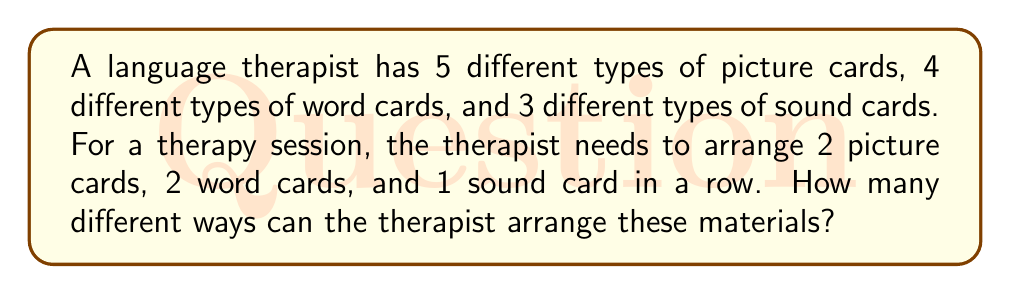Show me your answer to this math problem. Let's break this down step-by-step:

1) First, we need to choose the cards:
   - 2 picture cards out of 5: $\binom{5}{2}$
   - 2 word cards out of 4: $\binom{4}{2}$
   - 1 sound card out of 3: $\binom{3}{1}$

2) The number of ways to choose the cards is:
   $$\binom{5}{2} \cdot \binom{4}{2} \cdot \binom{3}{1}$$

3) Calculate each combination:
   $$\binom{5}{2} = \frac{5!}{2!(5-2)!} = \frac{5 \cdot 4}{2 \cdot 1} = 10$$
   $$\binom{4}{2} = \frac{4!}{2!(4-2)!} = \frac{4 \cdot 3}{2 \cdot 1} = 6$$
   $$\binom{3}{1} = \frac{3!}{1!(3-1)!} = 3$$

4) Multiply these results:
   $$10 \cdot 6 \cdot 3 = 180$$

5) Now, for each selection of cards, we need to arrange them in a row. This is a permutation of 5 items (2 picture cards, 2 word cards, 1 sound card).
   $$5! = 5 \cdot 4 \cdot 3 \cdot 2 \cdot 1 = 120$$

6) By the multiplication principle, the total number of ways to select and arrange the cards is:
   $$180 \cdot 120 = 21,600$$

Therefore, there are 21,600 different ways to arrange these therapy materials.
Answer: 21,600 